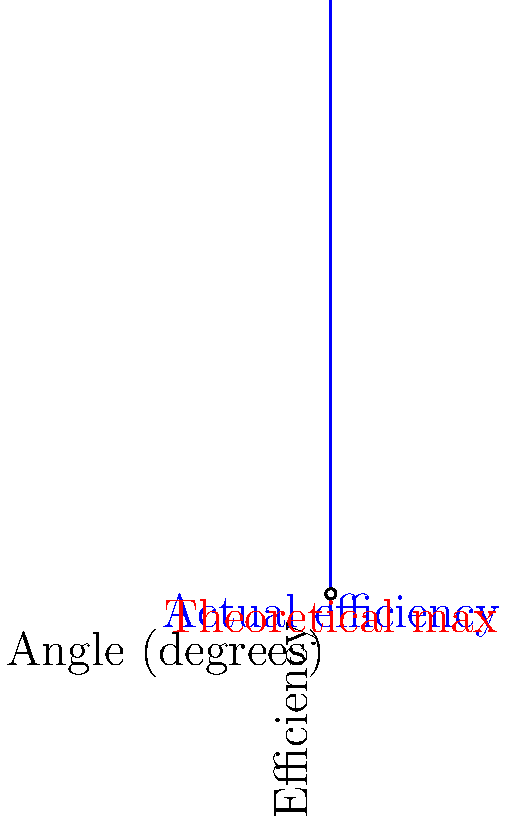As a chemical engineer advising an actress on the role of a scientist working on distillation column design, you're presented with the graph above showing the relationship between the angle of a distillation column and its efficiency. The blue curve represents the actual efficiency, while the red dashed line represents the theoretical maximum efficiency. At what angle (in degrees) does the actual efficiency reach its peak, and what is the corresponding efficiency value? To solve this problem, we need to follow these steps:

1) The actual efficiency curve (blue) is represented by a cubic function. Its maximum point will occur where the derivative of the function is zero.

2) From the graph, we can estimate that the maximum occurs around 30 degrees.

3) The efficiency function can be approximated as:

   $$f(x) = 0.8x^3 - 2.4x^2 + 1.8x + 0.6$$

   where $x$ is the angle in degrees and $f(x)$ is the efficiency.

4) To find the maximum, we differentiate $f(x)$ and set it to zero:

   $$f'(x) = 2.4x^2 - 4.8x + 1.8 = 0$$

5) This is a quadratic equation. We can solve it using the quadratic formula:

   $$x = \frac{-b \pm \sqrt{b^2 - 4ac}}{2a}$$

   where $a = 2.4$, $b = -4.8$, and $c = 1.8$

6) Solving this gives us $x \approx 30$ degrees (the other solution is outside our domain).

7) To find the efficiency at this angle, we plug $x = 30$ back into our original function:

   $$f(30) = 0.8(30)^3 - 2.4(30)^2 + 1.8(30) + 0.6 \approx 0.9$$

Therefore, the optimal angle is approximately 30 degrees, and the corresponding efficiency is about 0.9 or 90%.
Answer: 30 degrees, 90% efficiency 